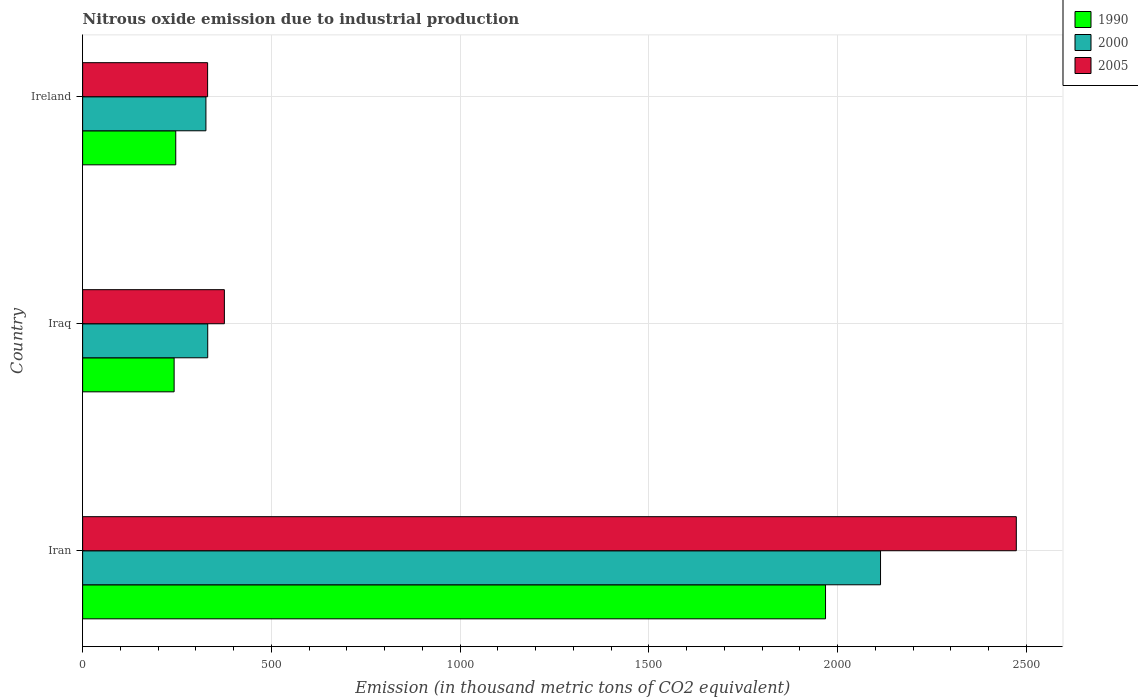How many different coloured bars are there?
Make the answer very short. 3. How many groups of bars are there?
Provide a short and direct response. 3. Are the number of bars on each tick of the Y-axis equal?
Your response must be concise. Yes. How many bars are there on the 2nd tick from the top?
Keep it short and to the point. 3. How many bars are there on the 2nd tick from the bottom?
Ensure brevity in your answer.  3. What is the label of the 2nd group of bars from the top?
Offer a very short reply. Iraq. What is the amount of nitrous oxide emitted in 2000 in Iraq?
Ensure brevity in your answer.  331.4. Across all countries, what is the maximum amount of nitrous oxide emitted in 2000?
Keep it short and to the point. 2113.8. Across all countries, what is the minimum amount of nitrous oxide emitted in 1990?
Offer a terse response. 242.4. In which country was the amount of nitrous oxide emitted in 2005 maximum?
Offer a terse response. Iran. In which country was the amount of nitrous oxide emitted in 2005 minimum?
Offer a terse response. Ireland. What is the total amount of nitrous oxide emitted in 2005 in the graph?
Offer a very short reply. 3180.1. What is the difference between the amount of nitrous oxide emitted in 2005 in Iran and that in Ireland?
Offer a terse response. 2142.4. What is the difference between the amount of nitrous oxide emitted in 2005 in Iraq and the amount of nitrous oxide emitted in 2000 in Iran?
Keep it short and to the point. -1738.3. What is the average amount of nitrous oxide emitted in 2005 per country?
Ensure brevity in your answer.  1060.03. What is the difference between the amount of nitrous oxide emitted in 2005 and amount of nitrous oxide emitted in 1990 in Ireland?
Provide a succinct answer. 84.4. In how many countries, is the amount of nitrous oxide emitted in 2005 greater than 2100 thousand metric tons?
Give a very brief answer. 1. What is the ratio of the amount of nitrous oxide emitted in 1990 in Iraq to that in Ireland?
Provide a succinct answer. 0.98. Is the amount of nitrous oxide emitted in 1990 in Iran less than that in Ireland?
Your response must be concise. No. What is the difference between the highest and the second highest amount of nitrous oxide emitted in 1990?
Ensure brevity in your answer.  1721.4. What is the difference between the highest and the lowest amount of nitrous oxide emitted in 1990?
Provide a succinct answer. 1725.7. In how many countries, is the amount of nitrous oxide emitted in 1990 greater than the average amount of nitrous oxide emitted in 1990 taken over all countries?
Offer a terse response. 1. Is the sum of the amount of nitrous oxide emitted in 2000 in Iraq and Ireland greater than the maximum amount of nitrous oxide emitted in 1990 across all countries?
Your response must be concise. No. What does the 3rd bar from the bottom in Ireland represents?
Give a very brief answer. 2005. How many bars are there?
Your answer should be compact. 9. How many countries are there in the graph?
Give a very brief answer. 3. Are the values on the major ticks of X-axis written in scientific E-notation?
Provide a short and direct response. No. What is the title of the graph?
Give a very brief answer. Nitrous oxide emission due to industrial production. What is the label or title of the X-axis?
Provide a short and direct response. Emission (in thousand metric tons of CO2 equivalent). What is the label or title of the Y-axis?
Ensure brevity in your answer.  Country. What is the Emission (in thousand metric tons of CO2 equivalent) in 1990 in Iran?
Provide a short and direct response. 1968.1. What is the Emission (in thousand metric tons of CO2 equivalent) of 2000 in Iran?
Your answer should be compact. 2113.8. What is the Emission (in thousand metric tons of CO2 equivalent) of 2005 in Iran?
Offer a very short reply. 2473.5. What is the Emission (in thousand metric tons of CO2 equivalent) of 1990 in Iraq?
Keep it short and to the point. 242.4. What is the Emission (in thousand metric tons of CO2 equivalent) of 2000 in Iraq?
Offer a very short reply. 331.4. What is the Emission (in thousand metric tons of CO2 equivalent) of 2005 in Iraq?
Provide a short and direct response. 375.5. What is the Emission (in thousand metric tons of CO2 equivalent) in 1990 in Ireland?
Offer a very short reply. 246.7. What is the Emission (in thousand metric tons of CO2 equivalent) of 2000 in Ireland?
Your answer should be compact. 326.6. What is the Emission (in thousand metric tons of CO2 equivalent) of 2005 in Ireland?
Make the answer very short. 331.1. Across all countries, what is the maximum Emission (in thousand metric tons of CO2 equivalent) of 1990?
Offer a very short reply. 1968.1. Across all countries, what is the maximum Emission (in thousand metric tons of CO2 equivalent) of 2000?
Keep it short and to the point. 2113.8. Across all countries, what is the maximum Emission (in thousand metric tons of CO2 equivalent) in 2005?
Provide a succinct answer. 2473.5. Across all countries, what is the minimum Emission (in thousand metric tons of CO2 equivalent) in 1990?
Your answer should be compact. 242.4. Across all countries, what is the minimum Emission (in thousand metric tons of CO2 equivalent) of 2000?
Offer a very short reply. 326.6. Across all countries, what is the minimum Emission (in thousand metric tons of CO2 equivalent) in 2005?
Your answer should be very brief. 331.1. What is the total Emission (in thousand metric tons of CO2 equivalent) of 1990 in the graph?
Your response must be concise. 2457.2. What is the total Emission (in thousand metric tons of CO2 equivalent) in 2000 in the graph?
Give a very brief answer. 2771.8. What is the total Emission (in thousand metric tons of CO2 equivalent) in 2005 in the graph?
Ensure brevity in your answer.  3180.1. What is the difference between the Emission (in thousand metric tons of CO2 equivalent) of 1990 in Iran and that in Iraq?
Ensure brevity in your answer.  1725.7. What is the difference between the Emission (in thousand metric tons of CO2 equivalent) of 2000 in Iran and that in Iraq?
Make the answer very short. 1782.4. What is the difference between the Emission (in thousand metric tons of CO2 equivalent) in 2005 in Iran and that in Iraq?
Ensure brevity in your answer.  2098. What is the difference between the Emission (in thousand metric tons of CO2 equivalent) of 1990 in Iran and that in Ireland?
Ensure brevity in your answer.  1721.4. What is the difference between the Emission (in thousand metric tons of CO2 equivalent) in 2000 in Iran and that in Ireland?
Offer a terse response. 1787.2. What is the difference between the Emission (in thousand metric tons of CO2 equivalent) of 2005 in Iran and that in Ireland?
Provide a short and direct response. 2142.4. What is the difference between the Emission (in thousand metric tons of CO2 equivalent) of 2005 in Iraq and that in Ireland?
Your response must be concise. 44.4. What is the difference between the Emission (in thousand metric tons of CO2 equivalent) in 1990 in Iran and the Emission (in thousand metric tons of CO2 equivalent) in 2000 in Iraq?
Keep it short and to the point. 1636.7. What is the difference between the Emission (in thousand metric tons of CO2 equivalent) in 1990 in Iran and the Emission (in thousand metric tons of CO2 equivalent) in 2005 in Iraq?
Provide a short and direct response. 1592.6. What is the difference between the Emission (in thousand metric tons of CO2 equivalent) of 2000 in Iran and the Emission (in thousand metric tons of CO2 equivalent) of 2005 in Iraq?
Give a very brief answer. 1738.3. What is the difference between the Emission (in thousand metric tons of CO2 equivalent) in 1990 in Iran and the Emission (in thousand metric tons of CO2 equivalent) in 2000 in Ireland?
Make the answer very short. 1641.5. What is the difference between the Emission (in thousand metric tons of CO2 equivalent) in 1990 in Iran and the Emission (in thousand metric tons of CO2 equivalent) in 2005 in Ireland?
Ensure brevity in your answer.  1637. What is the difference between the Emission (in thousand metric tons of CO2 equivalent) in 2000 in Iran and the Emission (in thousand metric tons of CO2 equivalent) in 2005 in Ireland?
Your response must be concise. 1782.7. What is the difference between the Emission (in thousand metric tons of CO2 equivalent) of 1990 in Iraq and the Emission (in thousand metric tons of CO2 equivalent) of 2000 in Ireland?
Provide a short and direct response. -84.2. What is the difference between the Emission (in thousand metric tons of CO2 equivalent) in 1990 in Iraq and the Emission (in thousand metric tons of CO2 equivalent) in 2005 in Ireland?
Make the answer very short. -88.7. What is the average Emission (in thousand metric tons of CO2 equivalent) of 1990 per country?
Your answer should be compact. 819.07. What is the average Emission (in thousand metric tons of CO2 equivalent) in 2000 per country?
Your answer should be very brief. 923.93. What is the average Emission (in thousand metric tons of CO2 equivalent) in 2005 per country?
Make the answer very short. 1060.03. What is the difference between the Emission (in thousand metric tons of CO2 equivalent) in 1990 and Emission (in thousand metric tons of CO2 equivalent) in 2000 in Iran?
Offer a very short reply. -145.7. What is the difference between the Emission (in thousand metric tons of CO2 equivalent) of 1990 and Emission (in thousand metric tons of CO2 equivalent) of 2005 in Iran?
Keep it short and to the point. -505.4. What is the difference between the Emission (in thousand metric tons of CO2 equivalent) of 2000 and Emission (in thousand metric tons of CO2 equivalent) of 2005 in Iran?
Provide a succinct answer. -359.7. What is the difference between the Emission (in thousand metric tons of CO2 equivalent) in 1990 and Emission (in thousand metric tons of CO2 equivalent) in 2000 in Iraq?
Offer a very short reply. -89. What is the difference between the Emission (in thousand metric tons of CO2 equivalent) of 1990 and Emission (in thousand metric tons of CO2 equivalent) of 2005 in Iraq?
Offer a very short reply. -133.1. What is the difference between the Emission (in thousand metric tons of CO2 equivalent) in 2000 and Emission (in thousand metric tons of CO2 equivalent) in 2005 in Iraq?
Give a very brief answer. -44.1. What is the difference between the Emission (in thousand metric tons of CO2 equivalent) of 1990 and Emission (in thousand metric tons of CO2 equivalent) of 2000 in Ireland?
Your answer should be very brief. -79.9. What is the difference between the Emission (in thousand metric tons of CO2 equivalent) of 1990 and Emission (in thousand metric tons of CO2 equivalent) of 2005 in Ireland?
Make the answer very short. -84.4. What is the ratio of the Emission (in thousand metric tons of CO2 equivalent) in 1990 in Iran to that in Iraq?
Make the answer very short. 8.12. What is the ratio of the Emission (in thousand metric tons of CO2 equivalent) of 2000 in Iran to that in Iraq?
Keep it short and to the point. 6.38. What is the ratio of the Emission (in thousand metric tons of CO2 equivalent) of 2005 in Iran to that in Iraq?
Make the answer very short. 6.59. What is the ratio of the Emission (in thousand metric tons of CO2 equivalent) of 1990 in Iran to that in Ireland?
Provide a succinct answer. 7.98. What is the ratio of the Emission (in thousand metric tons of CO2 equivalent) of 2000 in Iran to that in Ireland?
Give a very brief answer. 6.47. What is the ratio of the Emission (in thousand metric tons of CO2 equivalent) in 2005 in Iran to that in Ireland?
Give a very brief answer. 7.47. What is the ratio of the Emission (in thousand metric tons of CO2 equivalent) in 1990 in Iraq to that in Ireland?
Your answer should be very brief. 0.98. What is the ratio of the Emission (in thousand metric tons of CO2 equivalent) in 2000 in Iraq to that in Ireland?
Offer a very short reply. 1.01. What is the ratio of the Emission (in thousand metric tons of CO2 equivalent) of 2005 in Iraq to that in Ireland?
Offer a terse response. 1.13. What is the difference between the highest and the second highest Emission (in thousand metric tons of CO2 equivalent) in 1990?
Give a very brief answer. 1721.4. What is the difference between the highest and the second highest Emission (in thousand metric tons of CO2 equivalent) of 2000?
Offer a very short reply. 1782.4. What is the difference between the highest and the second highest Emission (in thousand metric tons of CO2 equivalent) in 2005?
Your response must be concise. 2098. What is the difference between the highest and the lowest Emission (in thousand metric tons of CO2 equivalent) of 1990?
Your answer should be very brief. 1725.7. What is the difference between the highest and the lowest Emission (in thousand metric tons of CO2 equivalent) of 2000?
Offer a very short reply. 1787.2. What is the difference between the highest and the lowest Emission (in thousand metric tons of CO2 equivalent) in 2005?
Keep it short and to the point. 2142.4. 